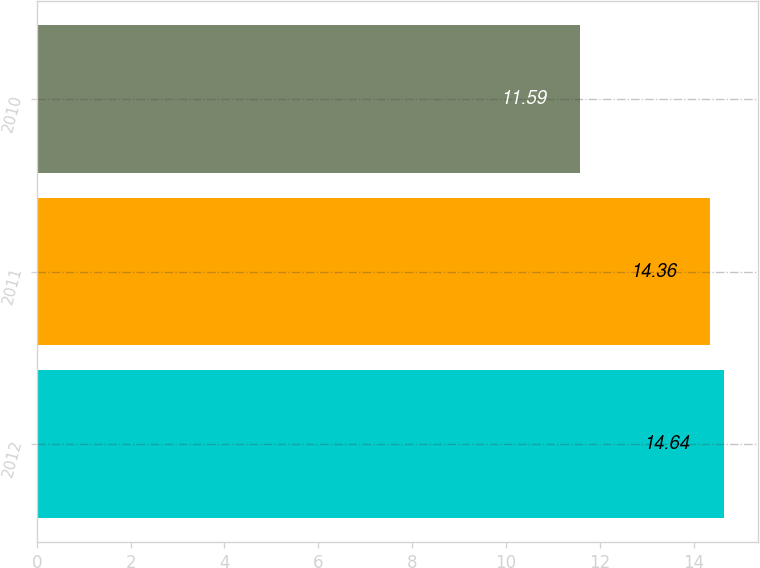<chart> <loc_0><loc_0><loc_500><loc_500><bar_chart><fcel>2012<fcel>2011<fcel>2010<nl><fcel>14.64<fcel>14.36<fcel>11.59<nl></chart> 